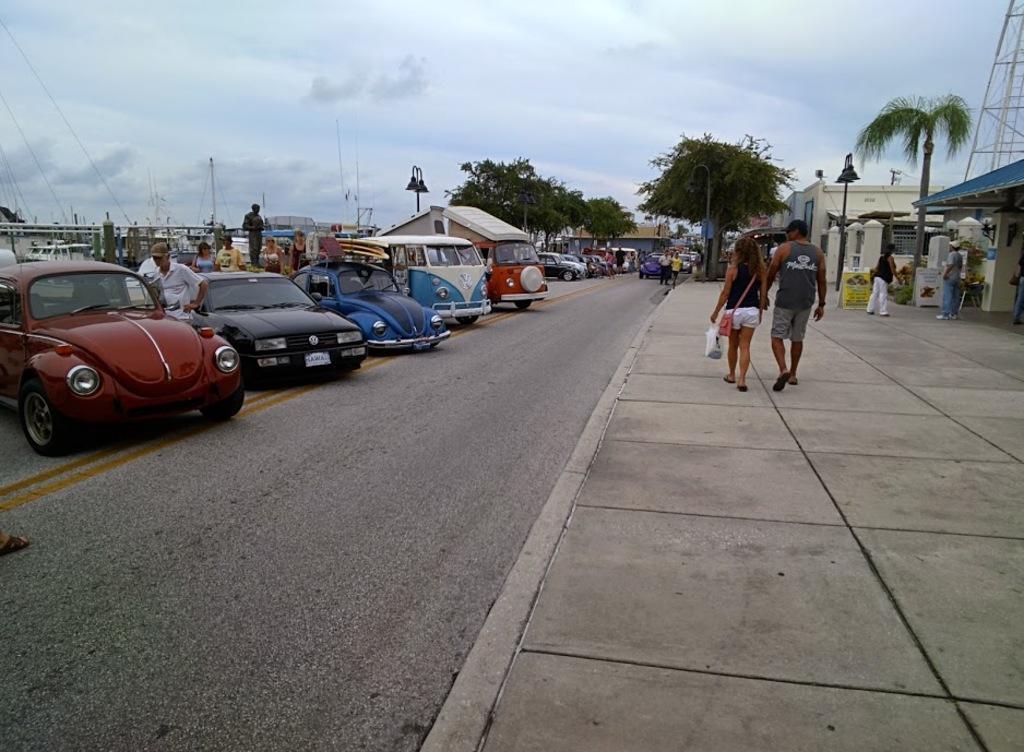In one or two sentences, can you explain what this image depicts? In this picture we can see vehicles on the road and a group of people where some are standing and some are walking on a footpath, boards, buildings, poles, trees and in the background we can see the sky with clouds. 